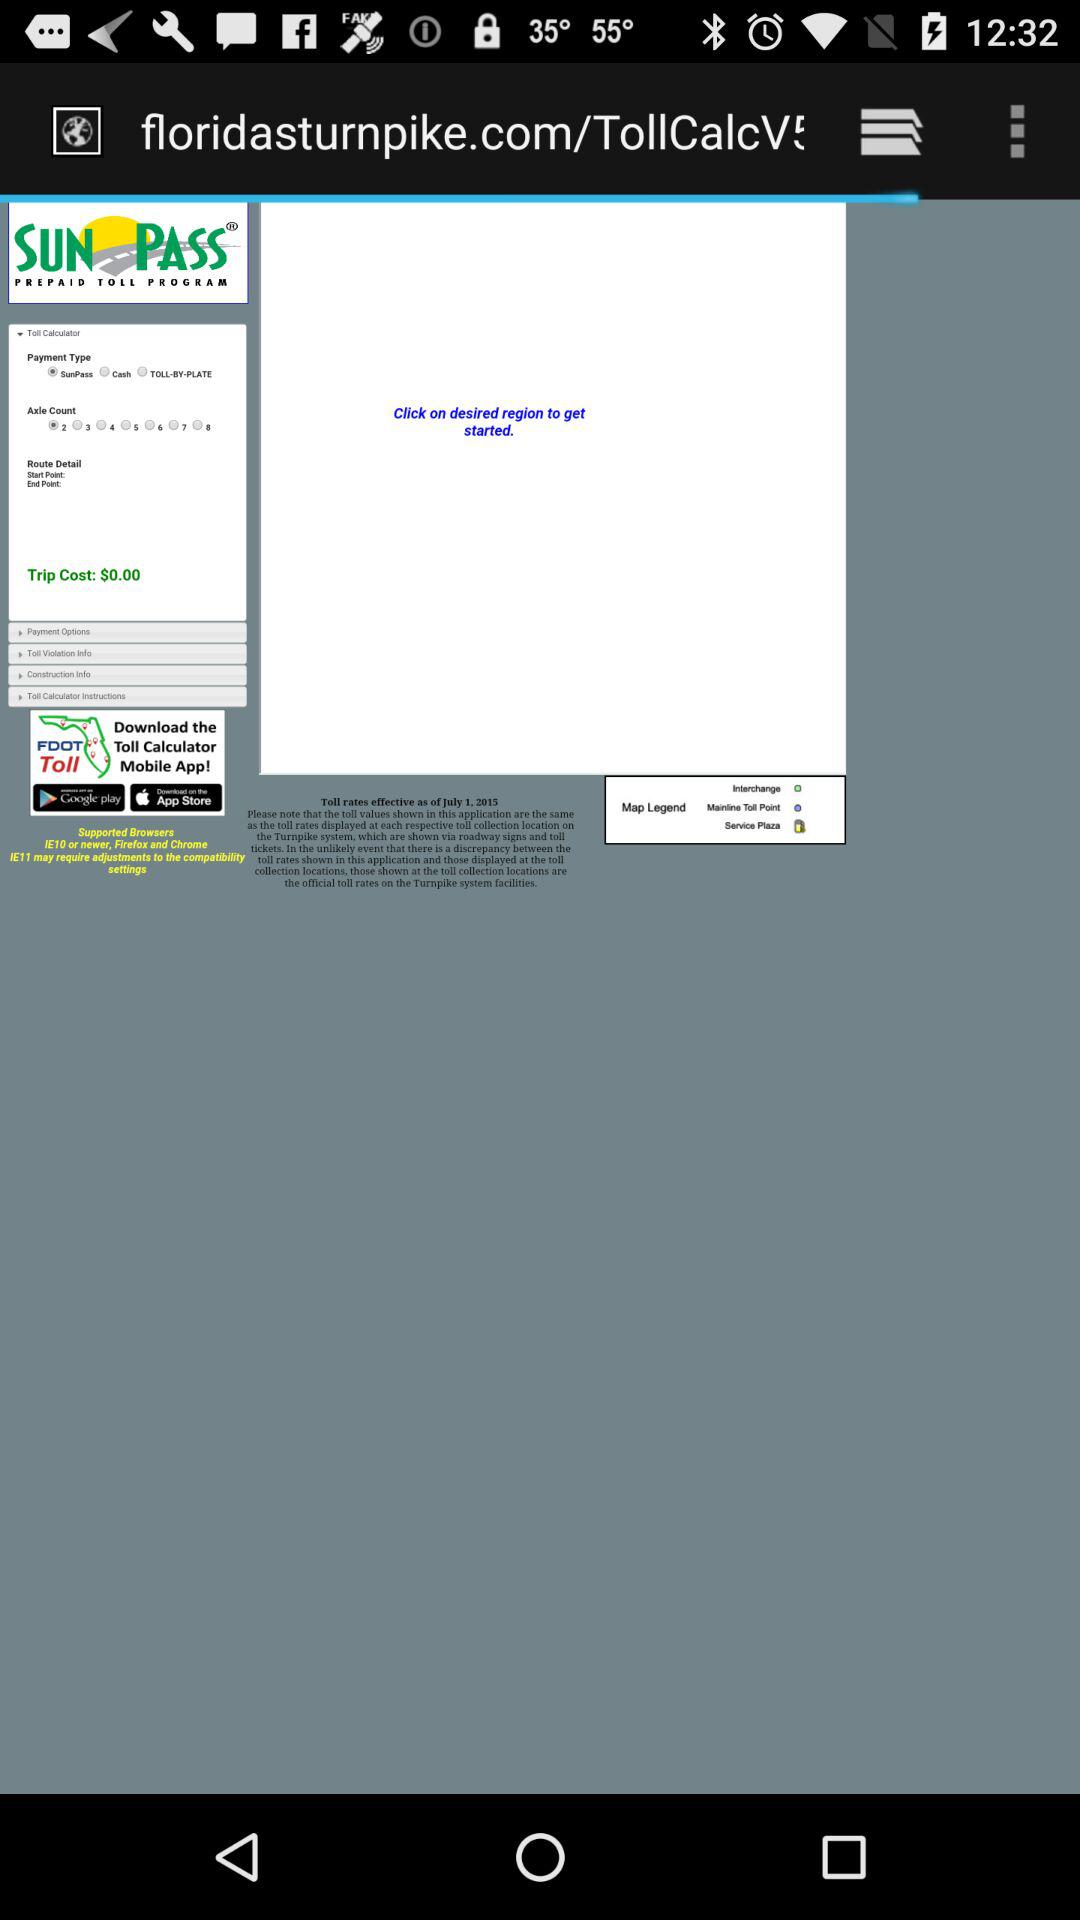What is the selected payment type? The selected payment type is "SunPass". 